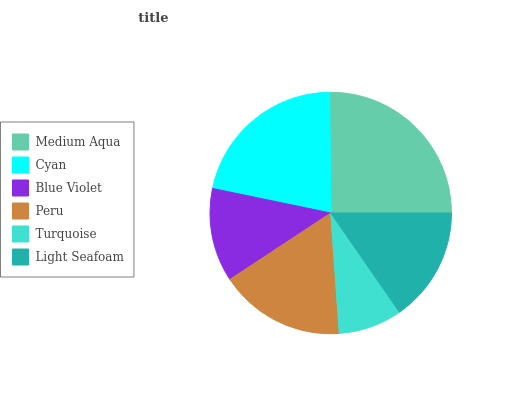Is Turquoise the minimum?
Answer yes or no. Yes. Is Medium Aqua the maximum?
Answer yes or no. Yes. Is Cyan the minimum?
Answer yes or no. No. Is Cyan the maximum?
Answer yes or no. No. Is Medium Aqua greater than Cyan?
Answer yes or no. Yes. Is Cyan less than Medium Aqua?
Answer yes or no. Yes. Is Cyan greater than Medium Aqua?
Answer yes or no. No. Is Medium Aqua less than Cyan?
Answer yes or no. No. Is Peru the high median?
Answer yes or no. Yes. Is Light Seafoam the low median?
Answer yes or no. Yes. Is Turquoise the high median?
Answer yes or no. No. Is Blue Violet the low median?
Answer yes or no. No. 